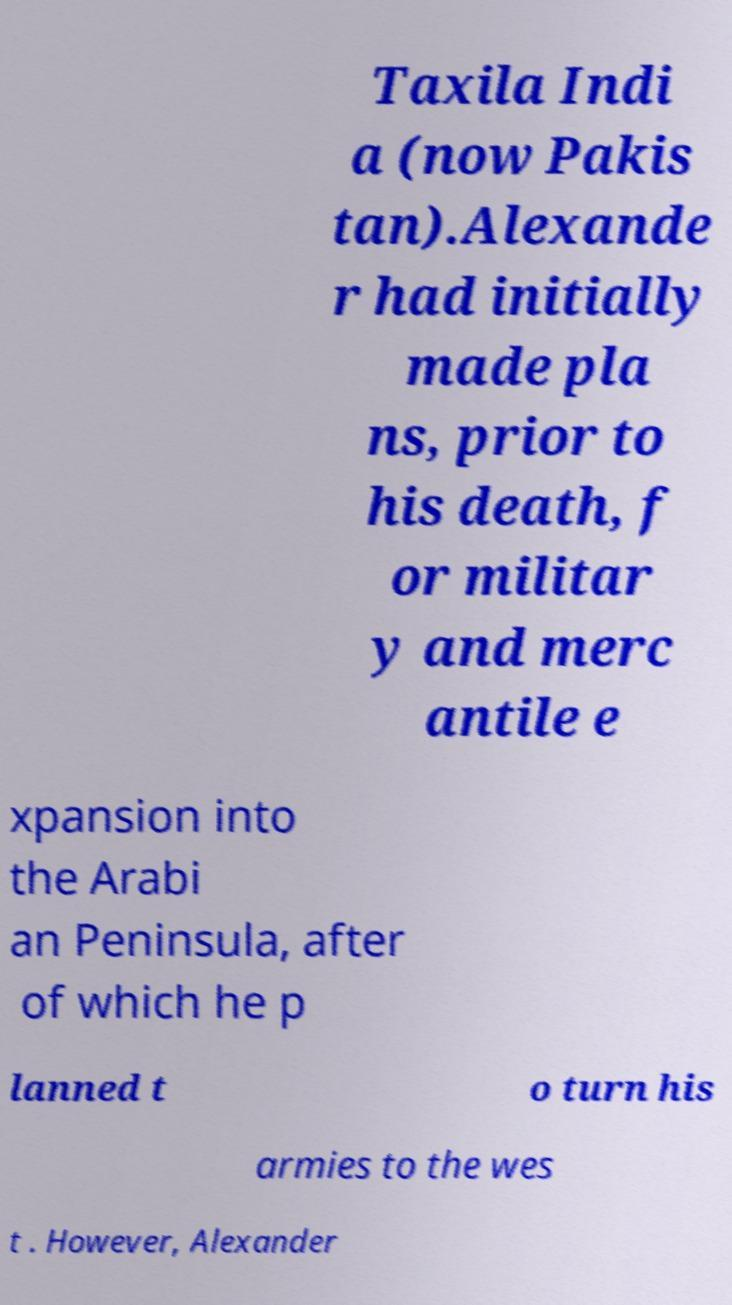What messages or text are displayed in this image? I need them in a readable, typed format. Taxila Indi a (now Pakis tan).Alexande r had initially made pla ns, prior to his death, f or militar y and merc antile e xpansion into the Arabi an Peninsula, after of which he p lanned t o turn his armies to the wes t . However, Alexander 